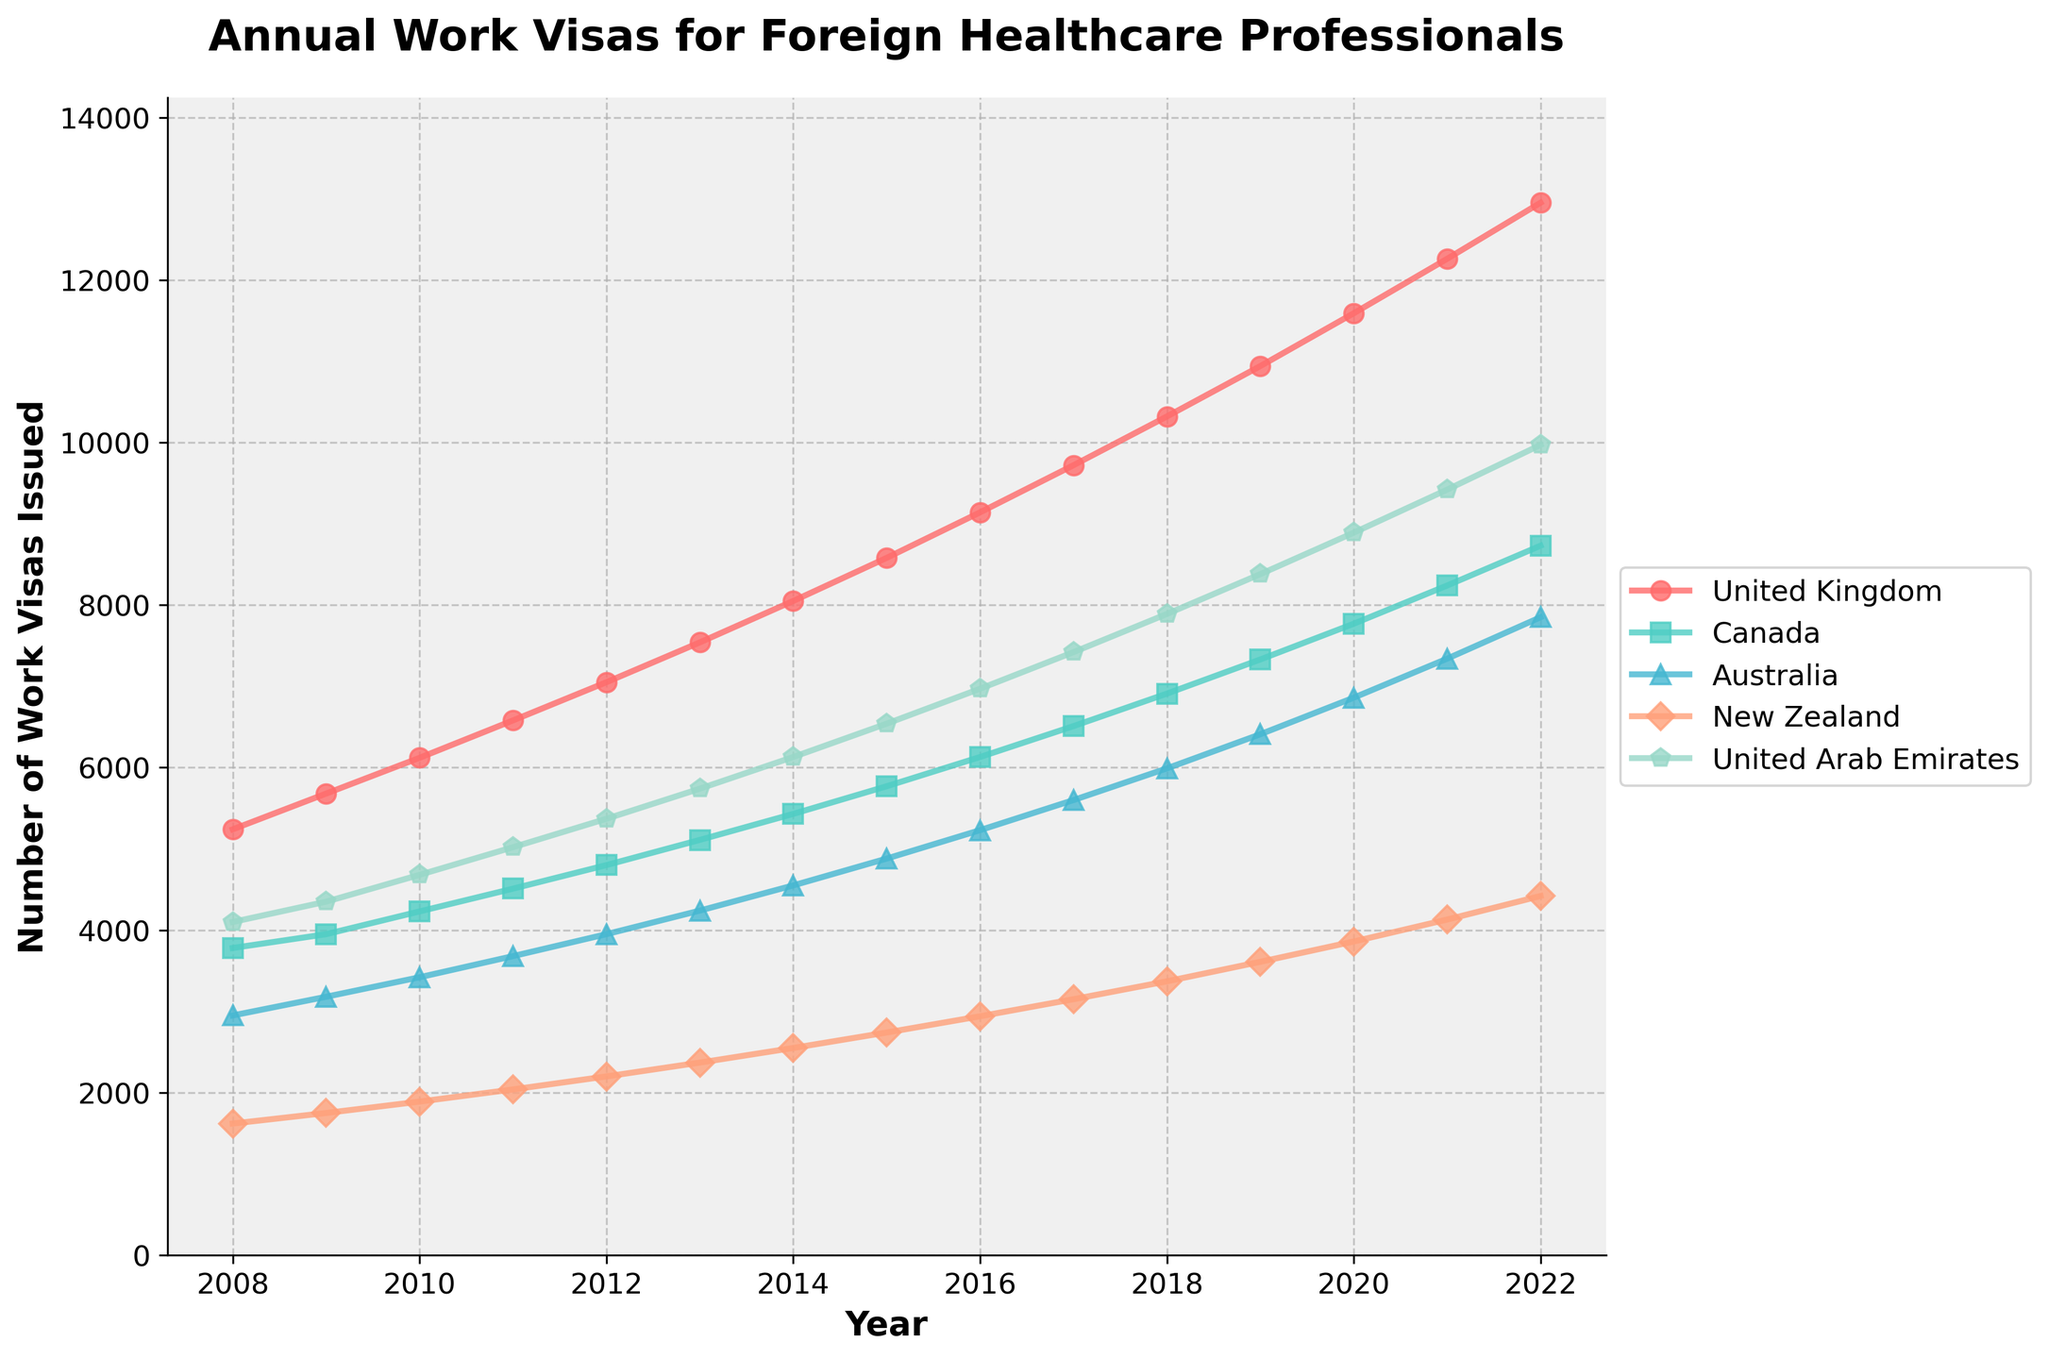What was the total number of work visas issued for healthcare professionals in the United Kingdom and Canada in 2015? First, find the values for the United Kingdom and Canada in 2015 from the data: 8580 (United Kingdom) and 5770 (Canada). Add these values together: 8580 + 5770.
Answer: 14350 What country had the highest number of work visas issued in 2022, and what was that number? Look at the values for 2022 for all countries to find the highest number. The highest number appears under the United Kingdom, which is 12950.
Answer: United Kingdom, 12950 Between which two consecutive years did Canada see the highest increase in the number of work visas issued? Find the difference in the number of work visas issued between each consecutive year for Canada. The highest increase is between 2021 (8240) and 2022 (8730), which is 8730 - 8240 = 490.
Answer: Between 2021 and 2022 What is the average number of work visas issued for Australia over the 15 years? Sum the number of work visas for Australia from 2008 to 2022 and then divide by 15. The sum is 2950 + 3180 + 3420 + 3680 + 3950 + 4240 + 4550 + 4880 + 5230 + 5600 + 5990 + 6410 + 6860 + 7340 + 7850 = 79630. Divide by 15 to find the average: 79630 / 15 = 5308.67.
Answer: 5308.67 Did New Zealand or the United Arab Emirates have a higher rate of increase in work visas issued from 2008 to 2022? Calculate the rate of increase for both countries: for New Zealand, the increase is from 1620 to 4420, a total increase of 4420 - 1620 = 2800. For the United Arab Emirates, the increase is from 4100 to 9970, a total increase of 9970 - 4100 = 5870. Compare the two rates: 2800 < 5870.
Answer: United Arab Emirates In which year did Australia surpass issuing 7000 work visas for the first time? Check the values for Australia from each year and identify the year the value exceeds 7000. The first year this happens is 2020 with 7340.
Answer: 2020 